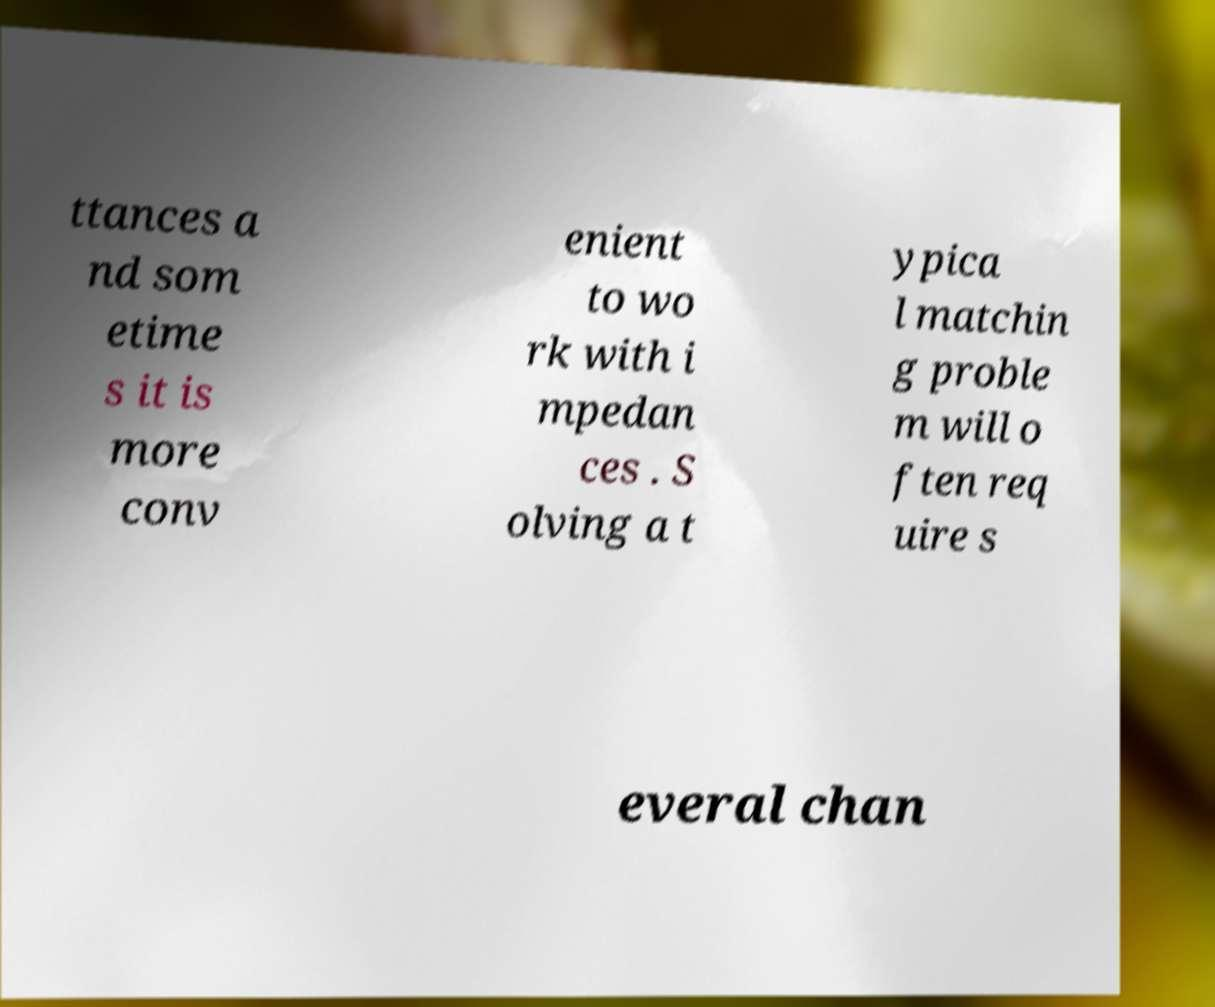Could you extract and type out the text from this image? ttances a nd som etime s it is more conv enient to wo rk with i mpedan ces . S olving a t ypica l matchin g proble m will o ften req uire s everal chan 